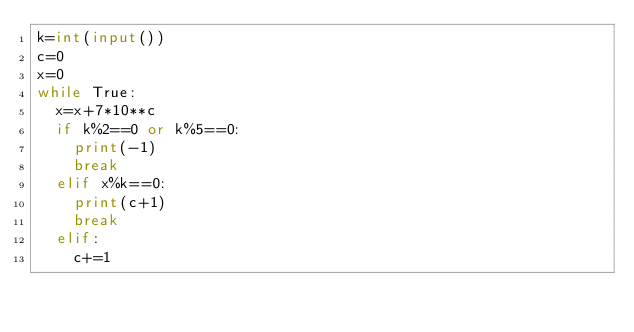<code> <loc_0><loc_0><loc_500><loc_500><_Python_>k=int(input())
c=0
x=0
while True:
  x=x+7*10**c
  if k%2==0 or k%5==0:
    print(-1)
    break
  elif x%k==0:
    print(c+1)
    break
  elif:
    c+=1</code> 